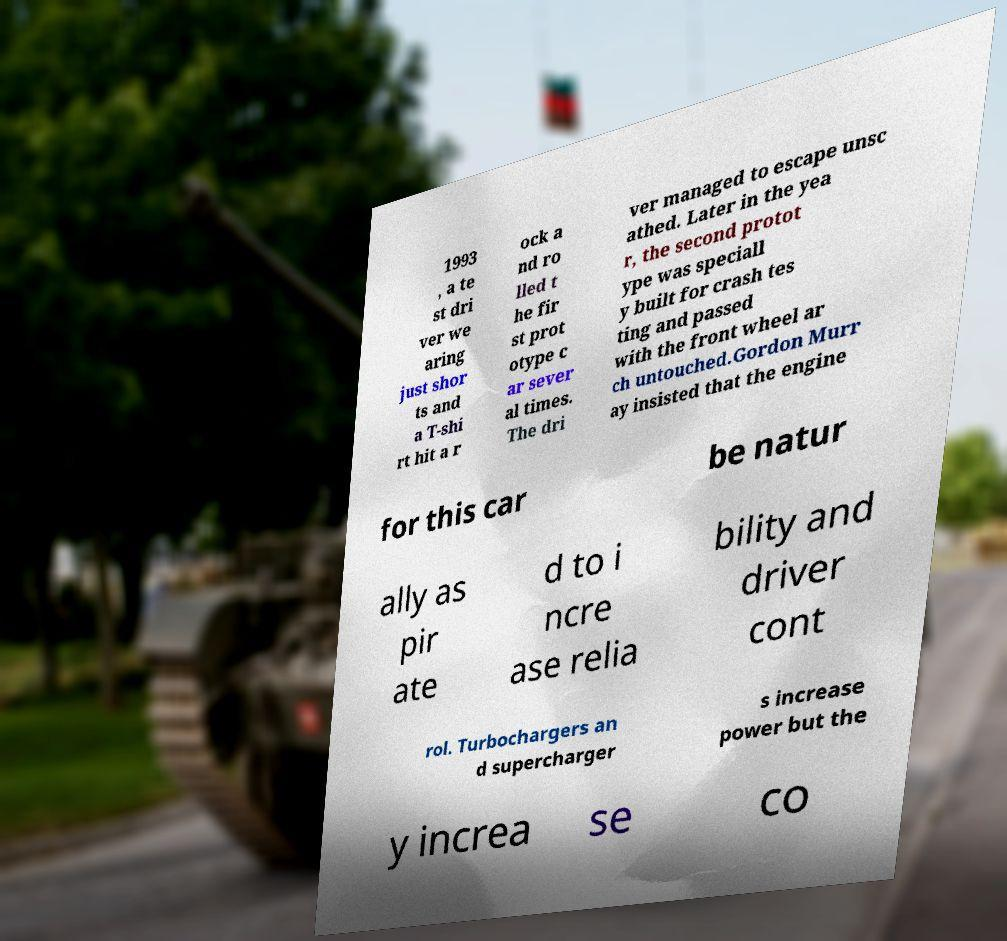For documentation purposes, I need the text within this image transcribed. Could you provide that? 1993 , a te st dri ver we aring just shor ts and a T-shi rt hit a r ock a nd ro lled t he fir st prot otype c ar sever al times. The dri ver managed to escape unsc athed. Later in the yea r, the second protot ype was speciall y built for crash tes ting and passed with the front wheel ar ch untouched.Gordon Murr ay insisted that the engine for this car be natur ally as pir ate d to i ncre ase relia bility and driver cont rol. Turbochargers an d supercharger s increase power but the y increa se co 